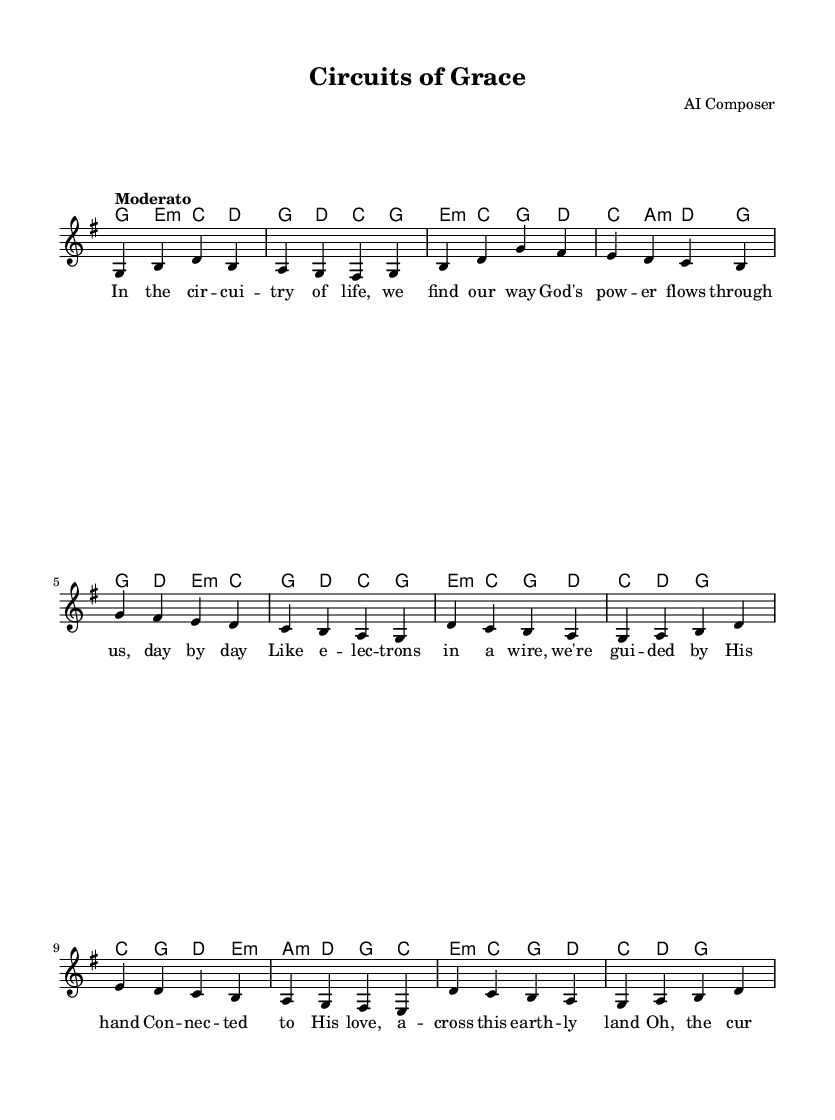What is the key signature of this music? The key signature is G major, which has one sharp (F#). This is determined by looking at the key signature indicated at the beginning of the sheet music.
Answer: G major What is the time signature of this music? The time signature is 4/4, indicated at the beginning of the score. This means there are four beats per measure, and the quarter note gets one beat.
Answer: 4/4 What is the tempo marking for this piece? The tempo marking is "Moderato," which indicates a moderate pace. This can be found above the staff in the score, indicating the speed at which the music should be played.
Answer: Moderato How many verses does this hymn have? The hymn consists of one verse, one chorus, and one bridge. By looking at the structure of the lyrics provided, we can see the distinct sections outlined.
Answer: One verse What metaphor related to electricity is used in the lyrics? The lyrics use the metaphor of "electrons in a wire" to describe guidance by God's hand. This phrase is specifically present in the first verse, linking faith with electrical concepts.
Answer: Electrons in a wire What is the primary theme of the hymn? The primary theme of the hymn is God's love and grace, illustrated through electrical metaphors like "current" and "power." This concept is woven throughout the lyrics, emphasizing connection and illumination.
Answer: God's love and grace 